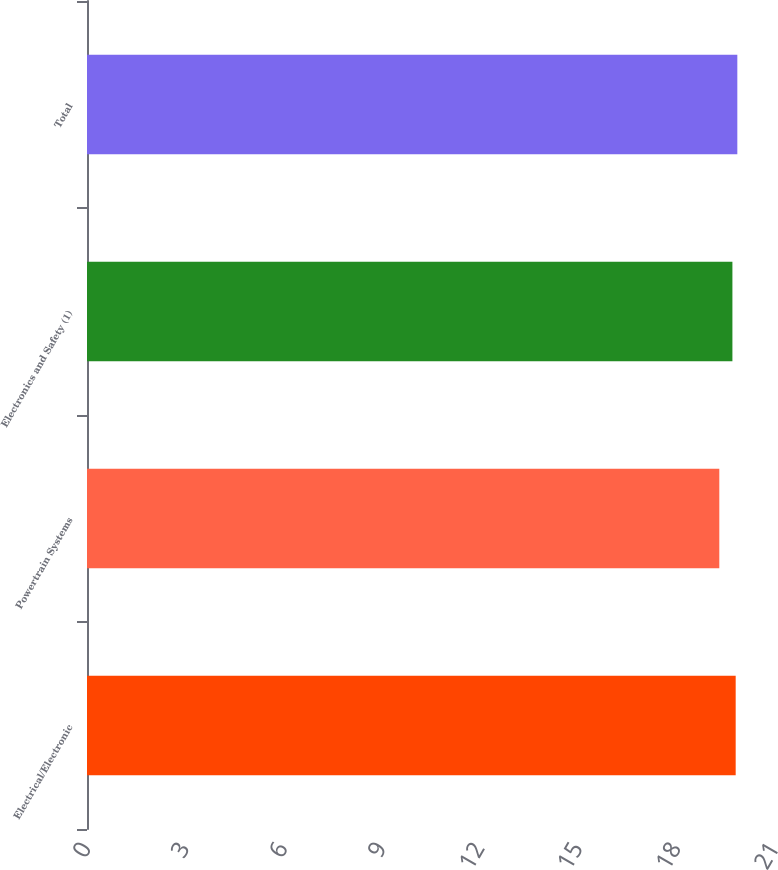Convert chart. <chart><loc_0><loc_0><loc_500><loc_500><bar_chart><fcel>Electrical/Electronic<fcel>Powertrain Systems<fcel>Electronics and Safety (1)<fcel>Total<nl><fcel>19.8<fcel>19.3<fcel>19.7<fcel>19.85<nl></chart> 